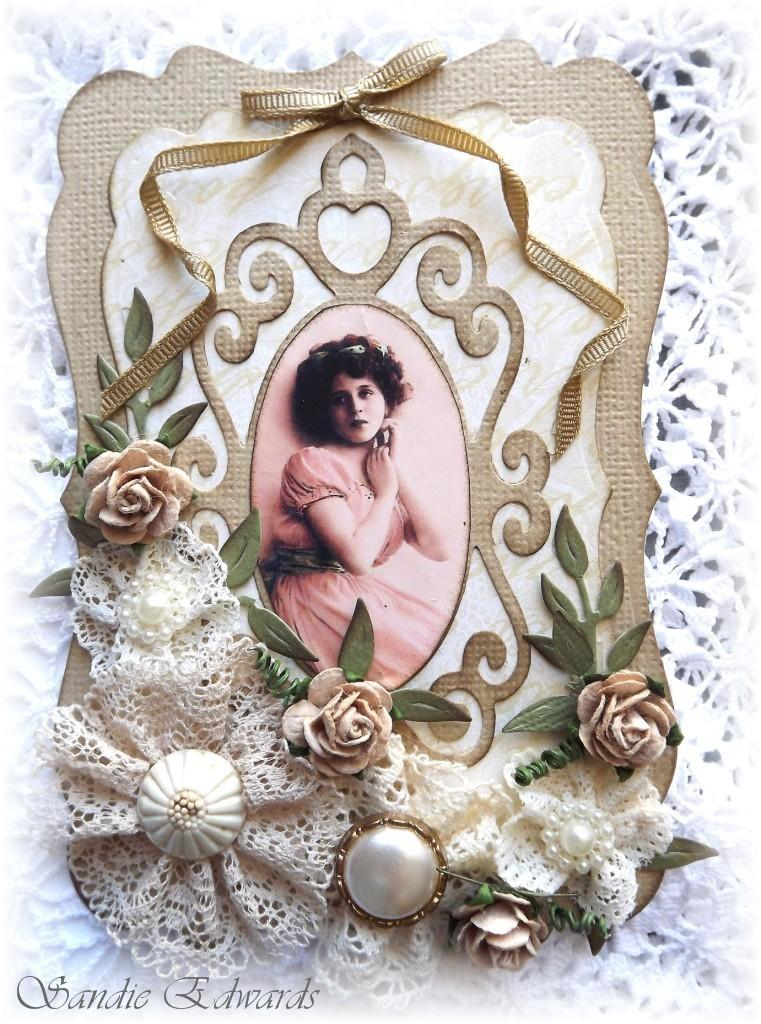What type of object is depicted in the image? The image appears to be a gift box. Can you describe any people or figures in the image? There is a woman in the image. Are there any decorative elements in the image? Yes, there are flowers in the image. Can you tell me how many times the woman jumps in the image? There is no indication of the woman jumping in the image; she is simply standing or posing. What type of animals can be seen at the zoo in the image? There is no zoo present in the image; it features a gift box with a woman and flowers. 